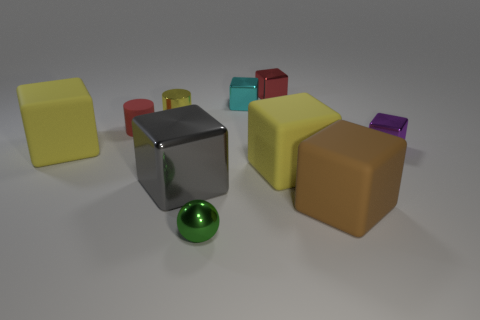The rubber thing that is both on the right side of the green metal sphere and to the left of the brown block has what shape?
Keep it short and to the point. Cube. Is the number of rubber cubes that are to the right of the gray metal thing greater than the number of tiny gray matte spheres?
Provide a short and direct response. Yes. There is a purple thing that is the same material as the yellow cylinder; what size is it?
Ensure brevity in your answer.  Small. How many other small things have the same color as the small matte thing?
Offer a terse response. 1. There is a rubber cube left of the red block; does it have the same color as the tiny metallic cylinder?
Offer a terse response. Yes. Is the number of shiny blocks that are in front of the large gray metal cube the same as the number of big brown blocks that are behind the yellow metallic thing?
Keep it short and to the point. Yes. Is there any other thing that is the same material as the green object?
Your response must be concise. Yes. There is a small shiny cube in front of the metallic cylinder; what is its color?
Offer a terse response. Purple. Are there an equal number of objects on the left side of the tiny sphere and shiny cubes?
Keep it short and to the point. Yes. How many other things are there of the same shape as the tiny green metal object?
Keep it short and to the point. 0. 